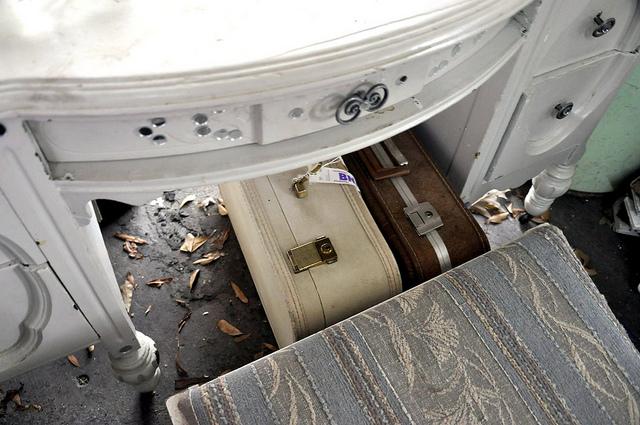Are the suitcases black?
Give a very brief answer. No. What is on the ground under the vanity?
Write a very short answer. Suitcases. Is there a brown suitcase?
Write a very short answer. Yes. 